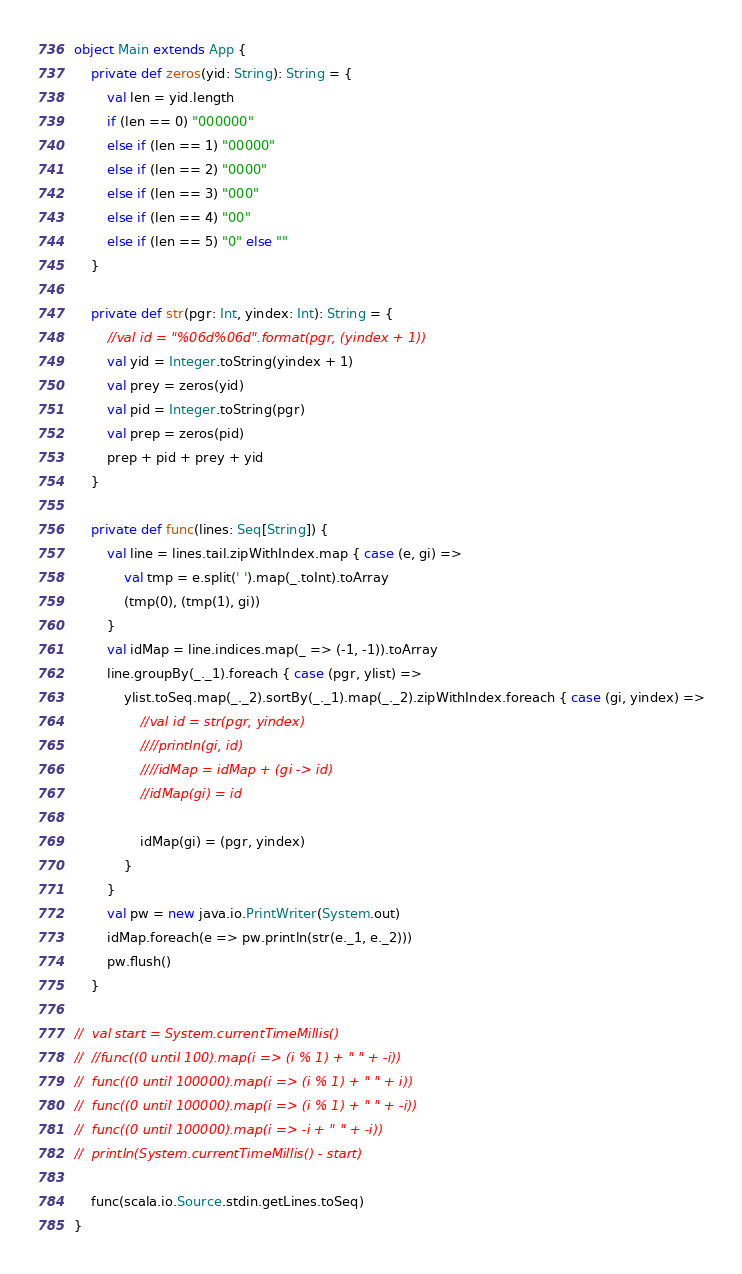Convert code to text. <code><loc_0><loc_0><loc_500><loc_500><_Scala_>object Main extends App {
	private def zeros(yid: String): String = {
		val len = yid.length
		if (len == 0) "000000"
		else if (len == 1) "00000"
		else if (len == 2) "0000"
		else if (len == 3) "000"
		else if (len == 4) "00"
		else if (len == 5) "0" else ""
	}

	private def str(pgr: Int, yindex: Int): String = {
		//val id = "%06d%06d".format(pgr, (yindex + 1))
		val yid = Integer.toString(yindex + 1)
		val prey = zeros(yid)
		val pid = Integer.toString(pgr)
		val prep = zeros(pid)
		prep + pid + prey + yid
	}

	private def func(lines: Seq[String]) {
		val line = lines.tail.zipWithIndex.map { case (e, gi) =>
			val tmp = e.split(' ').map(_.toInt).toArray
			(tmp(0), (tmp(1), gi))
		}
		val idMap = line.indices.map(_ => (-1, -1)).toArray
		line.groupBy(_._1).foreach { case (pgr, ylist) =>
			ylist.toSeq.map(_._2).sortBy(_._1).map(_._2).zipWithIndex.foreach { case (gi, yindex) =>
				//val id = str(pgr, yindex)
				////println(gi, id)
				////idMap = idMap + (gi -> id)
				//idMap(gi) = id

				idMap(gi) = (pgr, yindex)
			}
		}
		val pw = new java.io.PrintWriter(System.out)
		idMap.foreach(e => pw.println(str(e._1, e._2)))
		pw.flush()
	}

//	val start = System.currentTimeMillis()
//	//func((0 until 100).map(i => (i % 1) + " " + -i))
//	func((0 until 100000).map(i => (i % 1) + " " + i))
//	func((0 until 100000).map(i => (i % 1) + " " + -i))
//	func((0 until 100000).map(i => -i + " " + -i))
//	println(System.currentTimeMillis() - start)

	func(scala.io.Source.stdin.getLines.toSeq)
}
</code> 